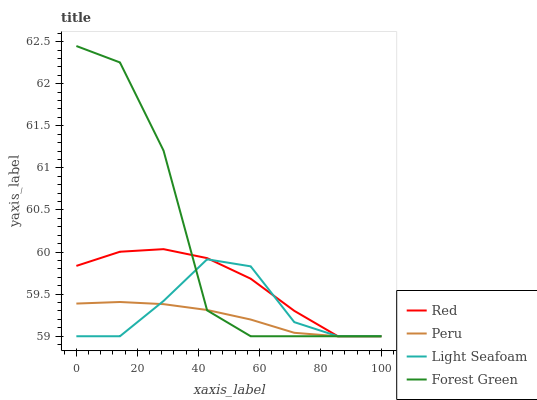Does Peru have the minimum area under the curve?
Answer yes or no. Yes. Does Forest Green have the maximum area under the curve?
Answer yes or no. Yes. Does Light Seafoam have the minimum area under the curve?
Answer yes or no. No. Does Light Seafoam have the maximum area under the curve?
Answer yes or no. No. Is Peru the smoothest?
Answer yes or no. Yes. Is Forest Green the roughest?
Answer yes or no. Yes. Is Light Seafoam the smoothest?
Answer yes or no. No. Is Light Seafoam the roughest?
Answer yes or no. No. Does Forest Green have the lowest value?
Answer yes or no. Yes. Does Forest Green have the highest value?
Answer yes or no. Yes. Does Light Seafoam have the highest value?
Answer yes or no. No. Does Forest Green intersect Red?
Answer yes or no. Yes. Is Forest Green less than Red?
Answer yes or no. No. Is Forest Green greater than Red?
Answer yes or no. No. 